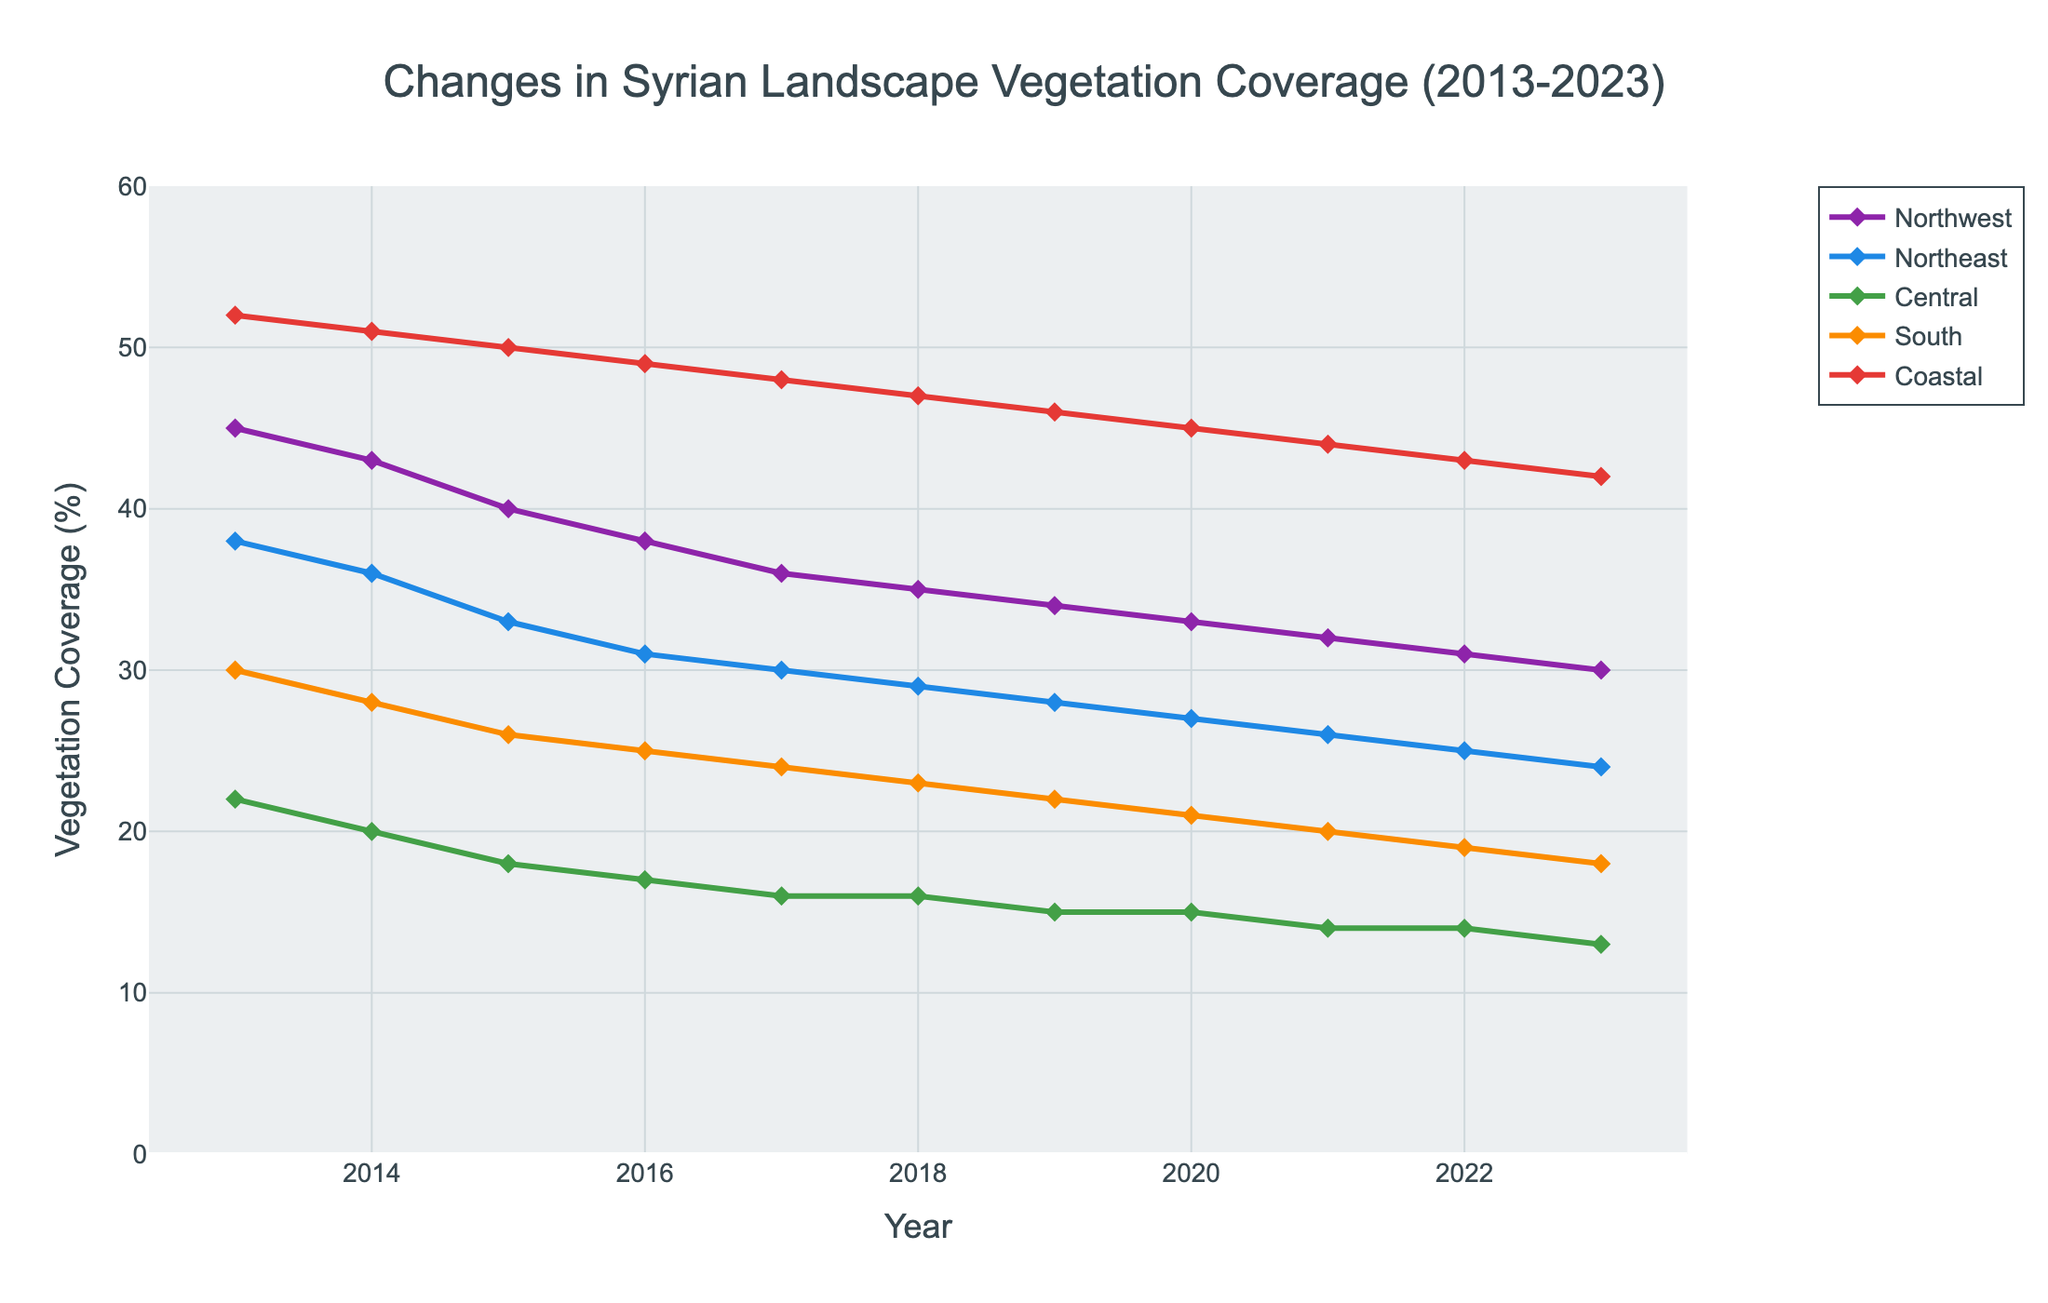What trend do you observe in the vegetation coverage of the Coastal region over the past decade? The vegetation coverage in the Coastal region shows a declining trend from 52% in 2013 to 42% in 2023.
Answer: Declining trend Which region had the highest vegetation coverage in 2018, and what was the percentage? In 2018, the Coastal region had the highest vegetation coverage, which was 47%.
Answer: Coastal, 47% By how many percentage points did the vegetation coverage in the Northwest region decrease from 2013 to 2023? The vegetation coverage in the Northwest region decreased from 45% in 2013 to 30% in 2023, which is a decrease of 45 - 30 = 15 percentage points.
Answer: 15 percentage points Between which years did the Northeast region experience its largest yearly drop in vegetation coverage? The largest yearly drop for the Northeast region happened between 2014 and 2015, with a decrease from 36% to 33%, which is a drop of 36 - 33 = 3 percentage points.
Answer: 2014 to 2015 What is the average vegetation coverage for the Central region over the entire decade? Summing the percentages for the Central region over the decade and dividing by the number of years: (22 + 20 + 18 + 17 + 16 + 16 + 15 + 15 + 14 + 14 + 13) / 11 = 180/11 ≈ 16.36%, rounded to two decimal places.
Answer: 16.36% How did the vegetation coverage in the South compare to the Central region in 2020? In 2020, the South had a vegetation coverage of 21%, while the Central region had 15%. This means the South had a higher vegetation coverage than the Central region by 21 - 15 = 6 percentage points.
Answer: South, 6 percentage points higher If the percentage decrease in Coastal region's vegetation coverage was consistently the same each year, what would be this annual percentage decrease? The decline over 10 years for the Coastal region is 52% - 42% = 10%. Dividing this by the 10-year period gives an annual decrease of 10 / 10 = 1% per year.
Answer: 1% per year Which region shows the least variability in vegetation coverage over the 10-year period? The Central region shows the least variability, with coverage changing from 22% to 13%. The difference is 22 - 13 = 9 percentage points over 10 years.
Answer: Central, 9 percentage points Does the visual layout suggest any outlier years for any of the regions? The visual layout of the data does not suggest any significant outlier year for any region, as all trends appear gradual without any abrupt changes.
Answer: No outliers 